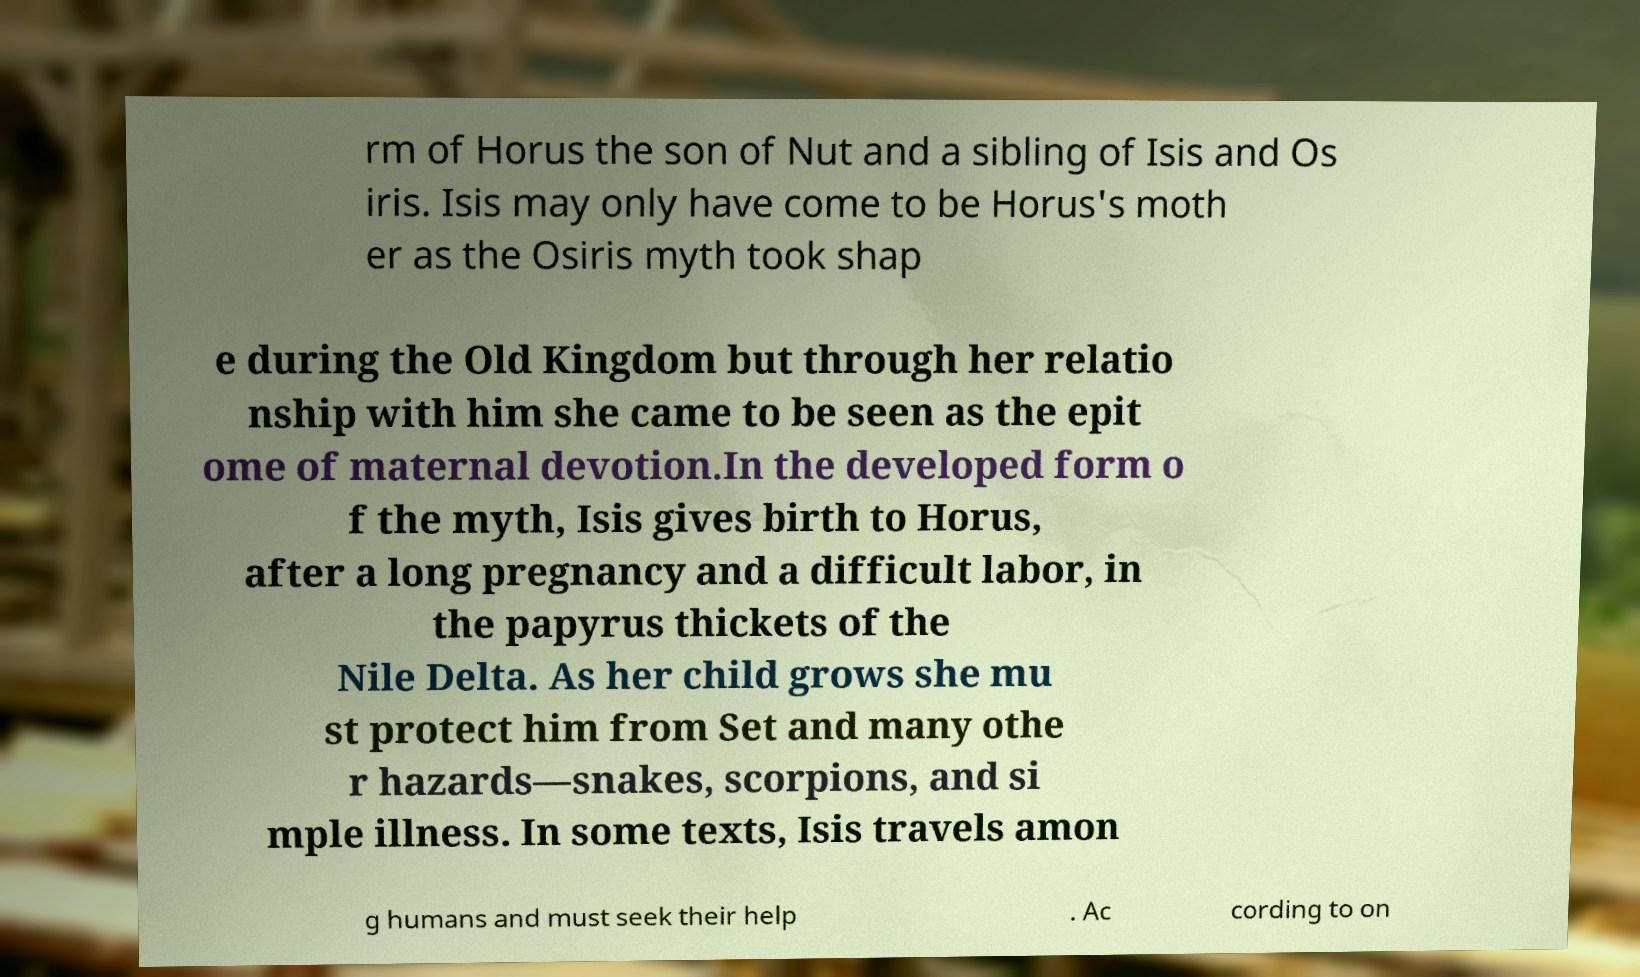Could you extract and type out the text from this image? rm of Horus the son of Nut and a sibling of Isis and Os iris. Isis may only have come to be Horus's moth er as the Osiris myth took shap e during the Old Kingdom but through her relatio nship with him she came to be seen as the epit ome of maternal devotion.In the developed form o f the myth, Isis gives birth to Horus, after a long pregnancy and a difficult labor, in the papyrus thickets of the Nile Delta. As her child grows she mu st protect him from Set and many othe r hazards—snakes, scorpions, and si mple illness. In some texts, Isis travels amon g humans and must seek their help . Ac cording to on 